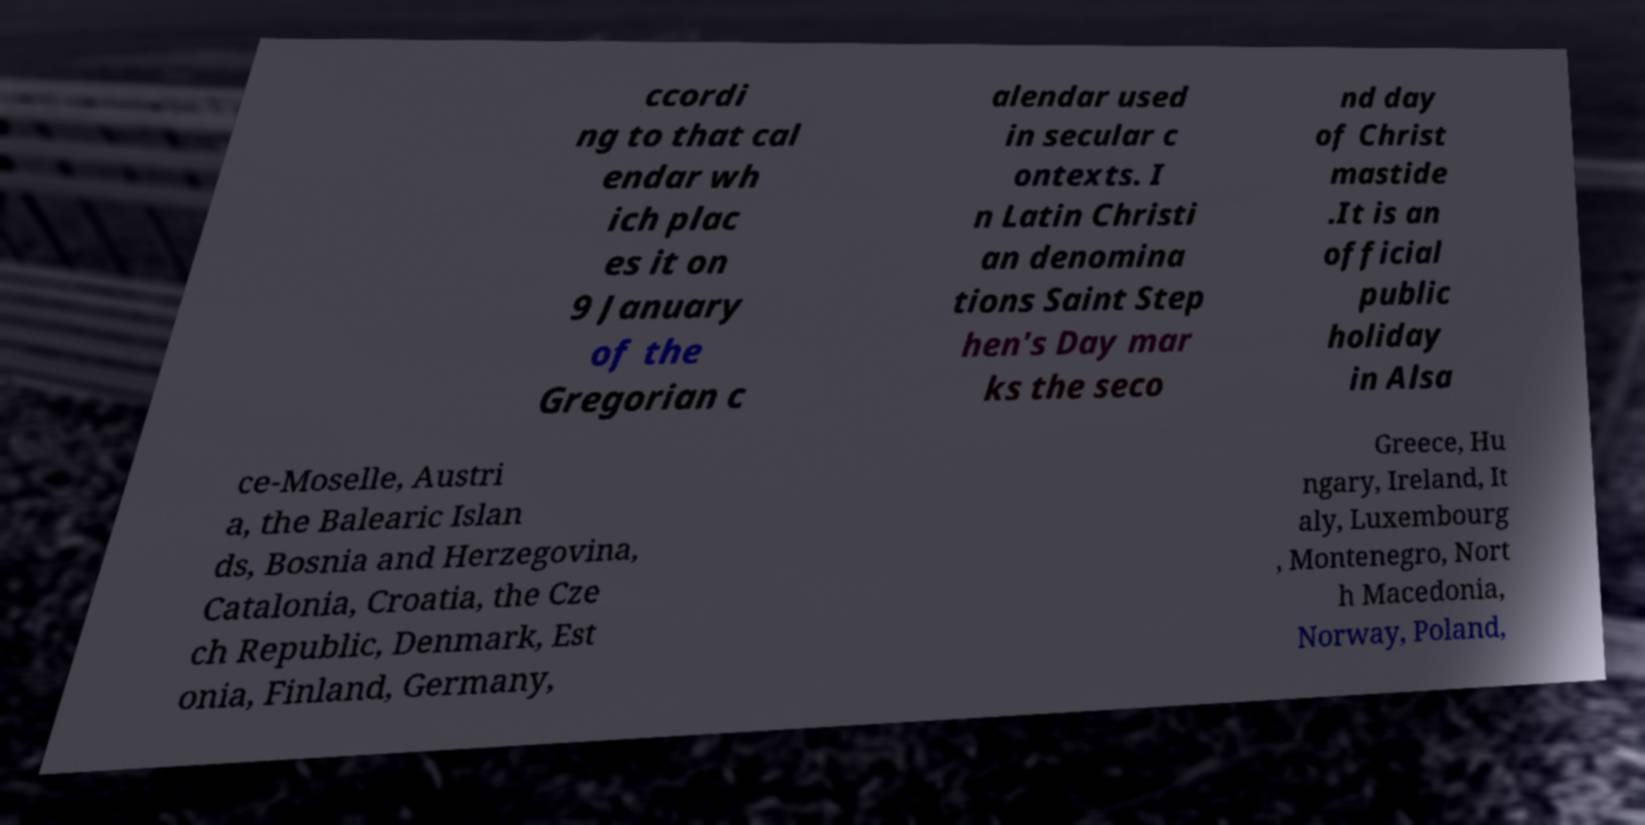Could you assist in decoding the text presented in this image and type it out clearly? ccordi ng to that cal endar wh ich plac es it on 9 January of the Gregorian c alendar used in secular c ontexts. I n Latin Christi an denomina tions Saint Step hen's Day mar ks the seco nd day of Christ mastide .It is an official public holiday in Alsa ce-Moselle, Austri a, the Balearic Islan ds, Bosnia and Herzegovina, Catalonia, Croatia, the Cze ch Republic, Denmark, Est onia, Finland, Germany, Greece, Hu ngary, Ireland, It aly, Luxembourg , Montenegro, Nort h Macedonia, Norway, Poland, 